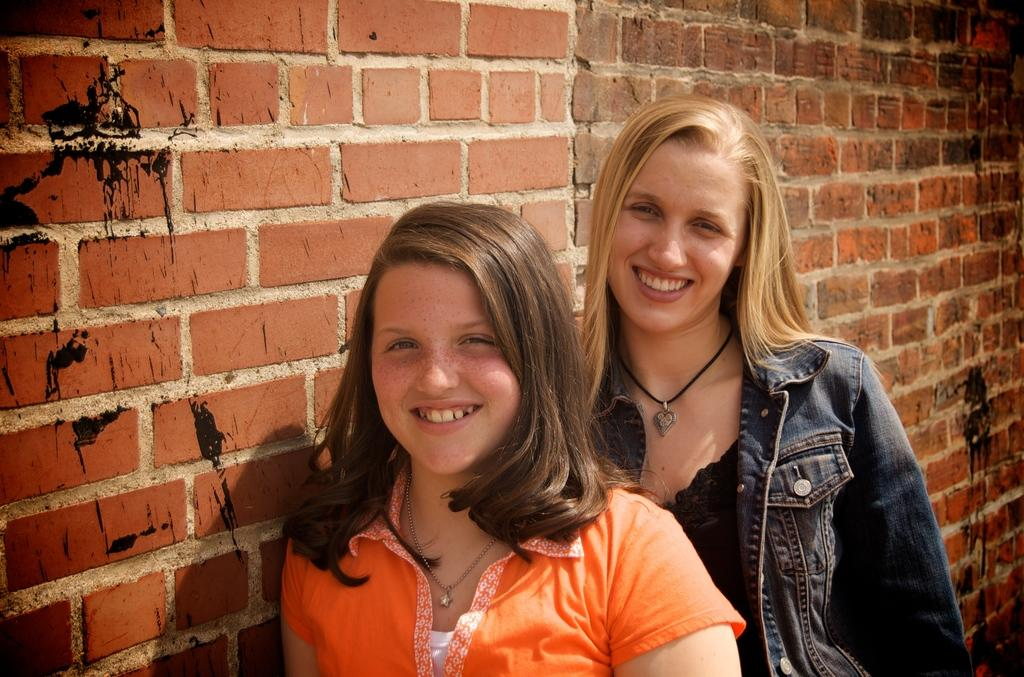How many people are in the image? There are two women in the image. What are the women doing in the image? The women are standing and smiling. What can be seen in the background of the image? There is a wall visible in the image. What type of guitar is the visitor playing in the image? There is no guitar or visitor present in the image. In which direction are the women facing in the image? The provided facts do not specify the direction the women are facing, so we cannot definitively answer this question. 